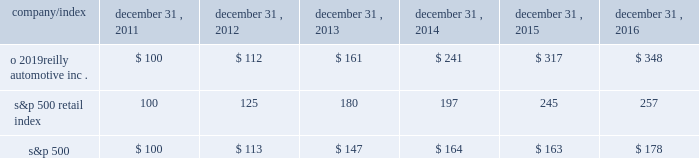Stock performance graph : the graph below shows the cumulative total shareholder return assuming the investment of $ 100 , on december 31 , 2011 , and the reinvestment of dividends thereafter , if any , in the company 2019s common stock versus the standard and poor 2019s s&p 500 retail index ( 201cs&p 500 retail index 201d ) and the standard and poor 2019s s&p 500 index ( 201cs&p 500 201d ) . .

What was the total five year return on o 2019reilly automotive inc.? 
Computations: (348 - 100)
Answer: 248.0. 